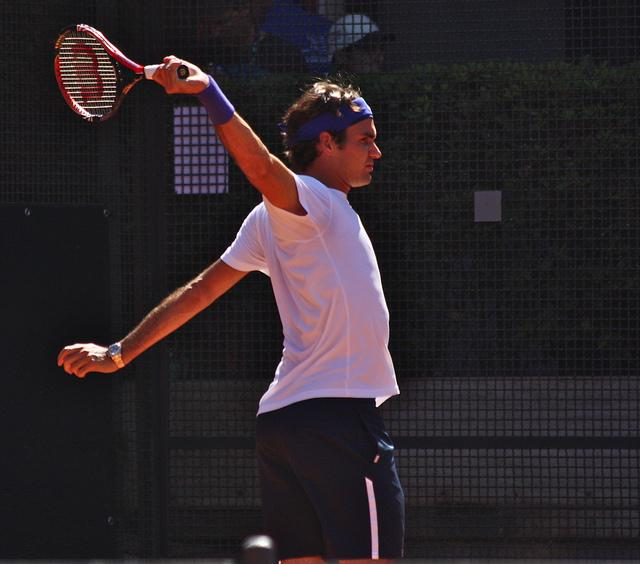What is the silver object on the man's wrist used for? Please explain your reasoning. telling time. It's a wristwatch obviously. 